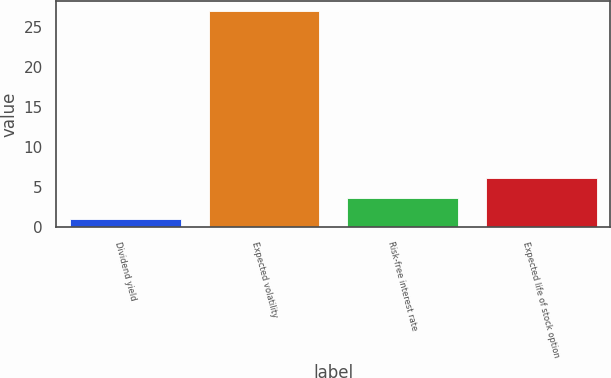Convert chart. <chart><loc_0><loc_0><loc_500><loc_500><bar_chart><fcel>Dividend yield<fcel>Expected volatility<fcel>Risk-free interest rate<fcel>Expected life of stock option<nl><fcel>1<fcel>27<fcel>3.6<fcel>6.2<nl></chart> 